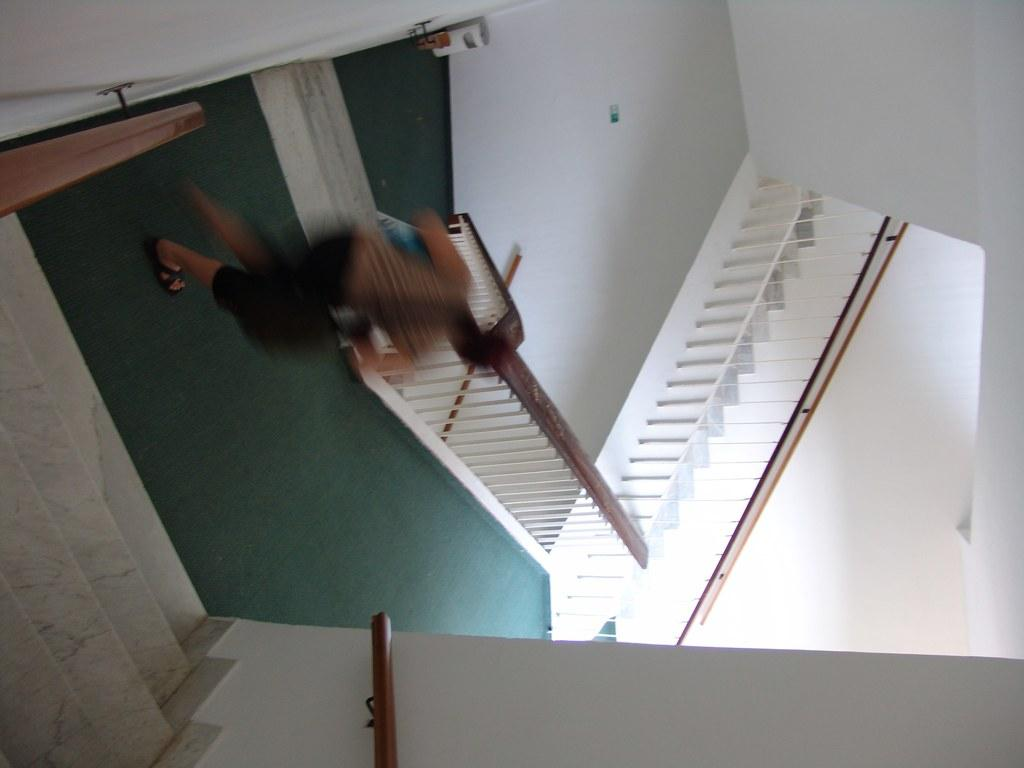What is present in the image? There is a person and stairs in the image. Can you describe the person in the image? The provided facts do not give any details about the person's appearance or clothing. What can be seen in the background of the image? The stairs are visible in the background of the image. What type of cheese is being raked by the person in the image? There is no cheese or rake present in the image. What color is the collar on the person in the image? The provided facts do not give any details about the person's appearance or clothing, including the presence of a collar. 